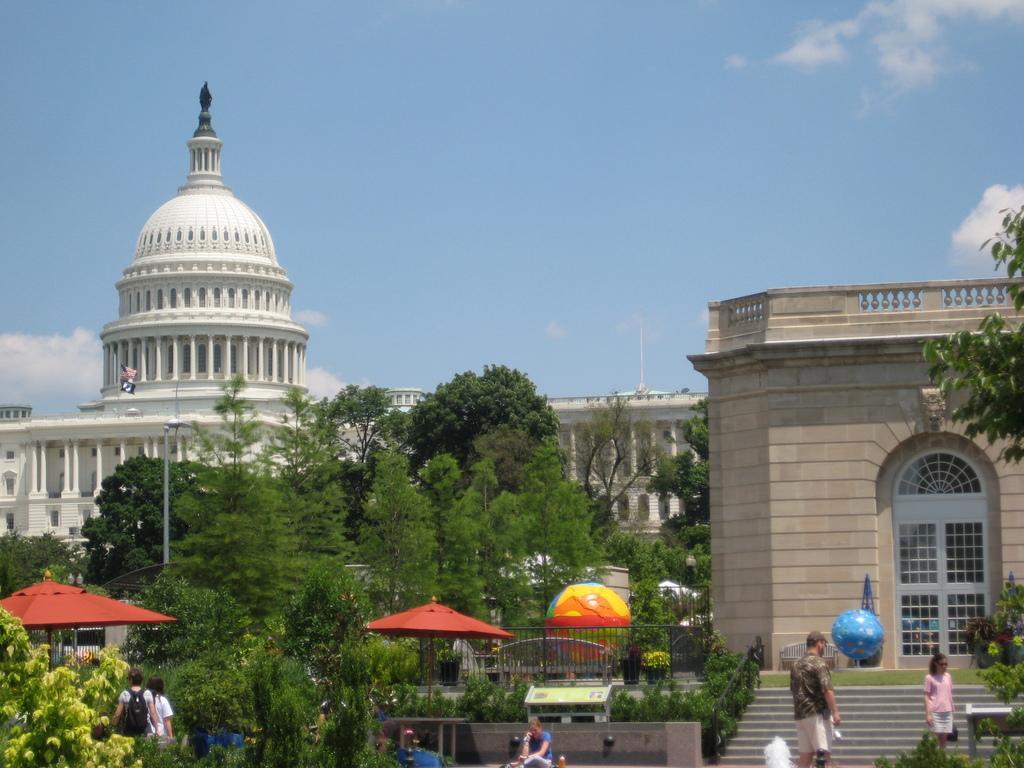Could you give a brief overview of what you see in this image? In this picture there are buildings and trees and there are umbrellas and there are group of people. At the back there is a railing and there is a flag and pole. On the right side of the image there is a staircase and there is a hand rail and there is an object and there is a board on the wall. At the top there is sky and there are clouds. 